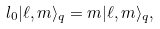<formula> <loc_0><loc_0><loc_500><loc_500>l _ { 0 } | \ell , m \rangle _ { q } = m | \ell , m \rangle _ { q } ,</formula> 